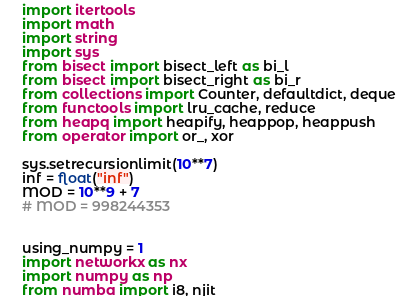Convert code to text. <code><loc_0><loc_0><loc_500><loc_500><_Python_>import itertools
import math
import string
import sys
from bisect import bisect_left as bi_l
from bisect import bisect_right as bi_r
from collections import Counter, defaultdict, deque
from functools import lru_cache, reduce
from heapq import heapify, heappop, heappush
from operator import or_, xor

sys.setrecursionlimit(10**7)
inf = float("inf")
MOD = 10**9 + 7
# MOD = 998244353


using_numpy = 1
import networkx as nx
import numpy as np
from numba import i8, njit</code> 